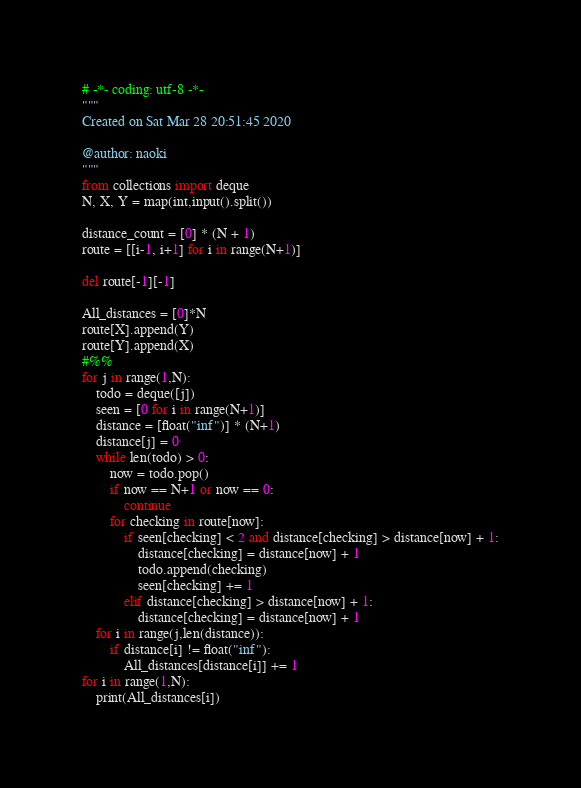<code> <loc_0><loc_0><loc_500><loc_500><_Python_># -*- coding: utf-8 -*-
"""
Created on Sat Mar 28 20:51:45 2020

@author: naoki
"""
from collections import deque
N, X, Y = map(int,input().split())

distance_count = [0] * (N + 1)
route = [[i-1, i+1] for i in range(N+1)]

del route[-1][-1]

All_distances = [0]*N
route[X].append(Y)
route[Y].append(X)
#%%
for j in range(1,N):
    todo = deque([j])
    seen = [0 for i in range(N+1)]
    distance = [float("inf")] * (N+1)
    distance[j] = 0
    while len(todo) > 0:
        now = todo.pop()
        if now == N+1 or now == 0:
            continue
        for checking in route[now]:
            if seen[checking] < 2 and distance[checking] > distance[now] + 1:
                distance[checking] = distance[now] + 1
                todo.append(checking)
                seen[checking] += 1
            elif distance[checking] > distance[now] + 1:
                distance[checking] = distance[now] + 1
    for i in range(j,len(distance)):
        if distance[i] != float("inf"):
            All_distances[distance[i]] += 1
for i in range(1,N):
    print(All_distances[i])</code> 